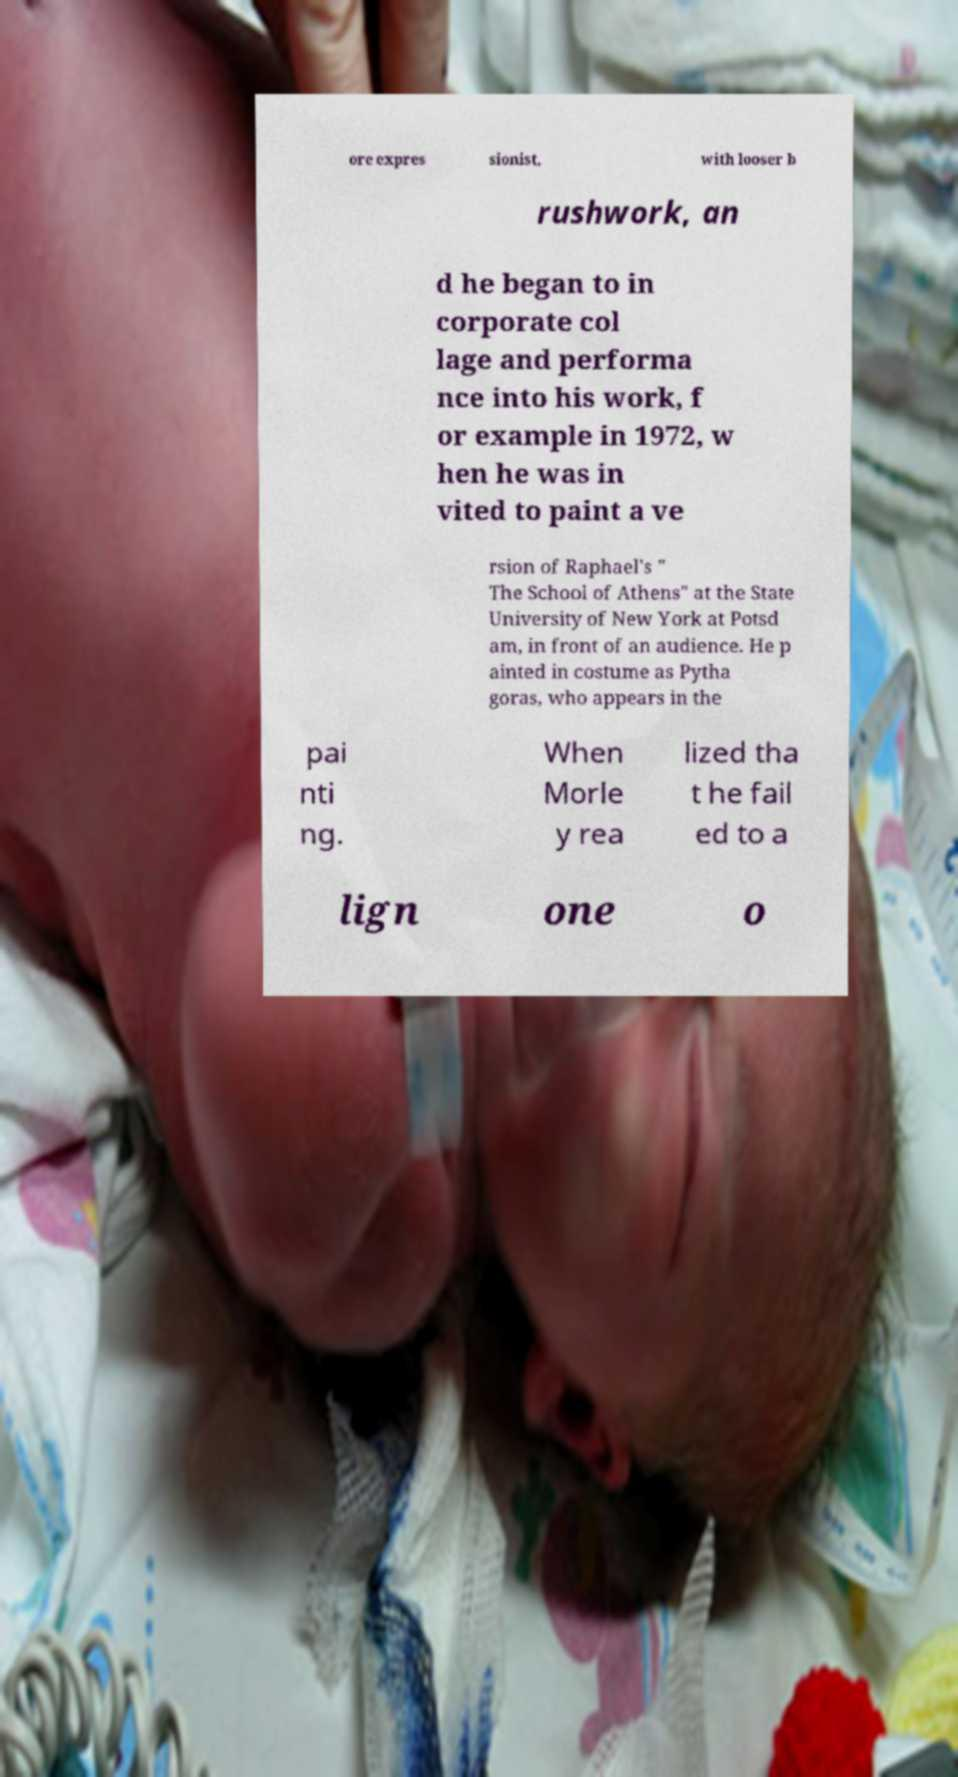Could you assist in decoding the text presented in this image and type it out clearly? ore expres sionist, with looser b rushwork, an d he began to in corporate col lage and performa nce into his work, f or example in 1972, w hen he was in vited to paint a ve rsion of Raphael's " The School of Athens" at the State University of New York at Potsd am, in front of an audience. He p ainted in costume as Pytha goras, who appears in the pai nti ng. When Morle y rea lized tha t he fail ed to a lign one o 